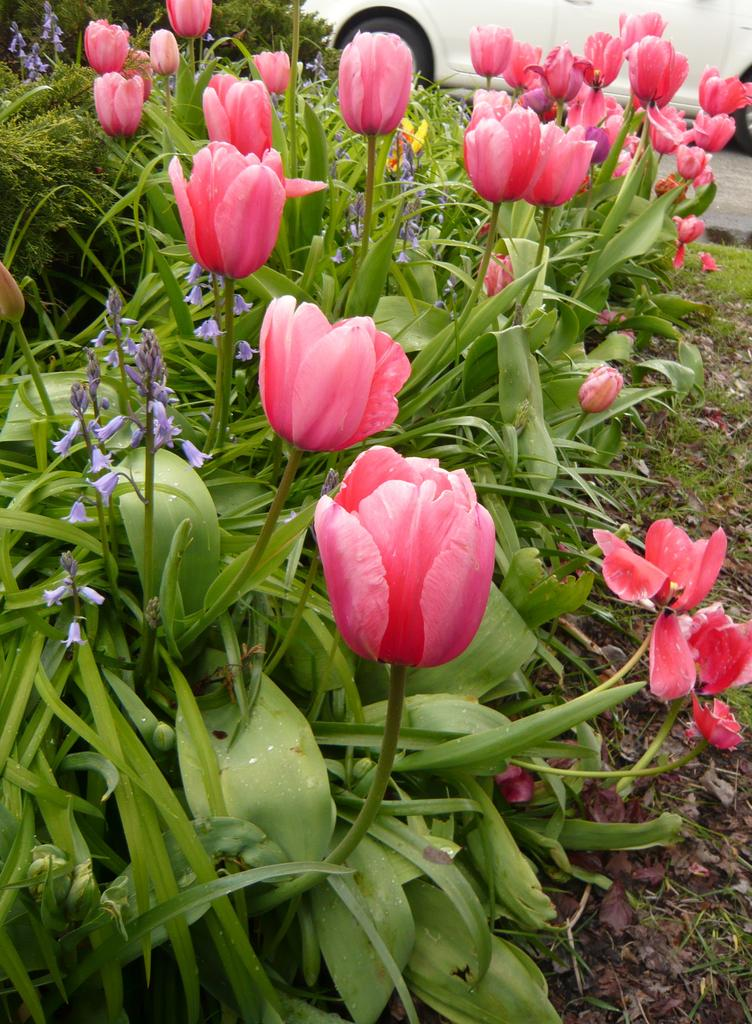What type of living organisms can be seen in the image? There are flowers in the image. Where are the flowers located? The flowers are on plants. What can be seen in the background of the image? There is a vehicle visible in the background of the image. How many apples are hanging from the plants in the image? There are no apples present in the image; it features flowers on plants. What type of wire is used to connect the beds in the image? There are no beds present in the image, so there is no wire connecting them. 